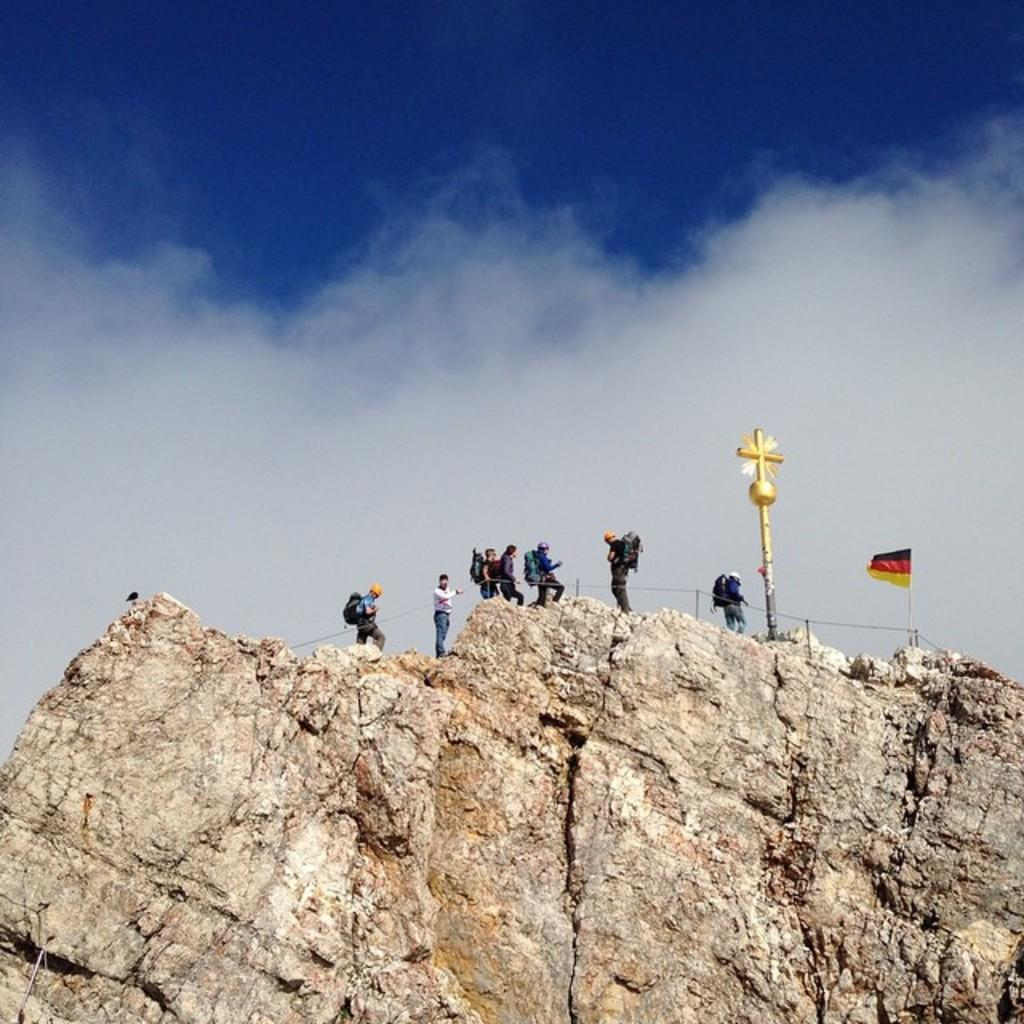What is located at the bottom of the image? There is a mountain at the bottom of the image. What is on the mountain? A: There is a flag, a cross, and a fence on the mountain. Are there any people on the mountain? Yes, there are persons on the mountain. What can be seen in the sky in the background of the image? There are clouds in the sky in the background of the image. What type of lumber is being used to construct the fence on the mountain? There is no mention of lumber or any specific construction material for the fence in the image. 